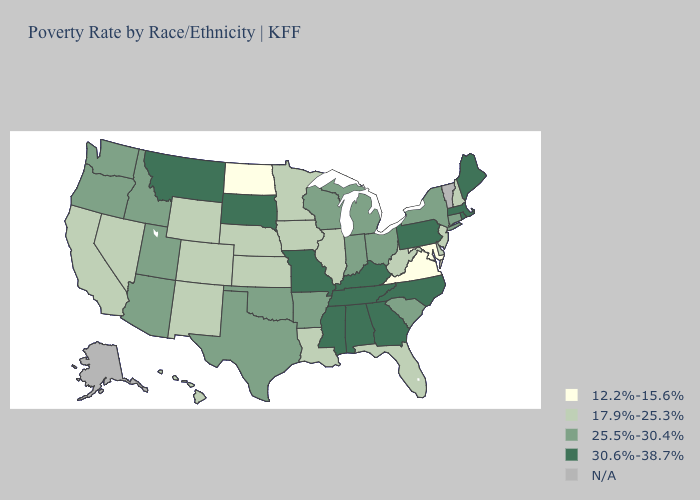What is the value of Florida?
Concise answer only. 17.9%-25.3%. Among the states that border Utah , which have the highest value?
Keep it brief. Arizona, Idaho. What is the value of Michigan?
Quick response, please. 25.5%-30.4%. What is the value of Oklahoma?
Answer briefly. 25.5%-30.4%. Among the states that border Maryland , does Delaware have the lowest value?
Concise answer only. No. Which states have the highest value in the USA?
Keep it brief. Alabama, Georgia, Kentucky, Maine, Massachusetts, Mississippi, Missouri, Montana, North Carolina, Pennsylvania, Rhode Island, South Dakota, Tennessee. What is the value of Texas?
Answer briefly. 25.5%-30.4%. What is the value of Mississippi?
Be succinct. 30.6%-38.7%. What is the highest value in states that border Vermont?
Concise answer only. 30.6%-38.7%. Does Arizona have the lowest value in the West?
Keep it brief. No. What is the value of Oregon?
Give a very brief answer. 25.5%-30.4%. Name the states that have a value in the range 17.9%-25.3%?
Concise answer only. California, Colorado, Delaware, Florida, Hawaii, Illinois, Iowa, Kansas, Louisiana, Minnesota, Nebraska, Nevada, New Hampshire, New Jersey, New Mexico, West Virginia, Wyoming. Name the states that have a value in the range 25.5%-30.4%?
Be succinct. Arizona, Arkansas, Connecticut, Idaho, Indiana, Michigan, New York, Ohio, Oklahoma, Oregon, South Carolina, Texas, Utah, Washington, Wisconsin. What is the value of Montana?
Concise answer only. 30.6%-38.7%. 